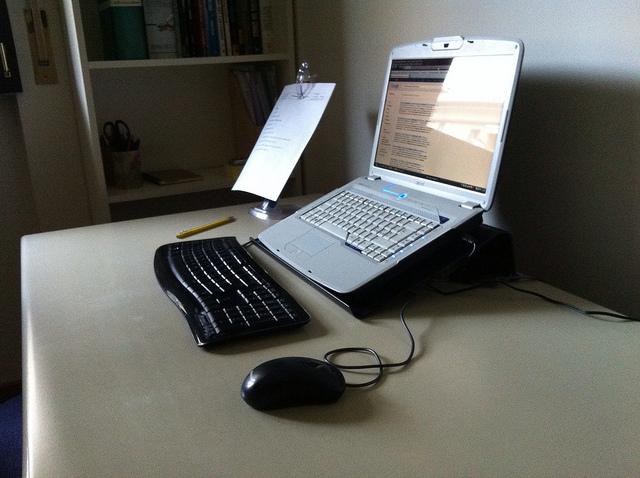What is underneath the mouse?
Write a very short answer. Desk. Is the desk lamp on?
Give a very brief answer. No. What is the laptop leaning on?
Keep it brief. Stand. Is this the desk of an organized person?
Short answer required. Yes. Is this a real computer?
Give a very brief answer. Yes. What color is the mouse on the right?
Keep it brief. Black. Are these all laptops?
Answer briefly. Yes. Is the mouse on a mouse pad?
Answer briefly. No. How many buttons are here?
Concise answer only. 100. Is this picture taken in a bedroom?
Concise answer only. No. Is this scenario totally wireless?
Keep it brief. No. Is the mouse wired or wireless?
Quick response, please. Wired. What is the laptop computer doing open?
Be succinct. In operation. Is the mouse cordless?
Keep it brief. No. What is the table made of?
Short answer required. Plastic. Who is using the laptop?
Answer briefly. No one. What color is the computer keyboard?
Write a very short answer. Black. 